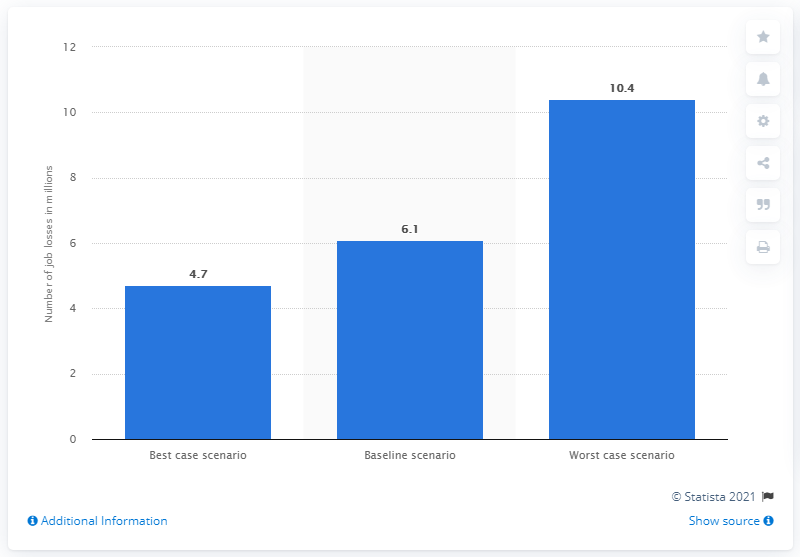List a handful of essential elements in this visual. According to estimates, up to 4.7 tourism jobs may be lost in the region in 2020. The travel and tourism sector is expected to lose approximately 10.4 jobs in 2020. 